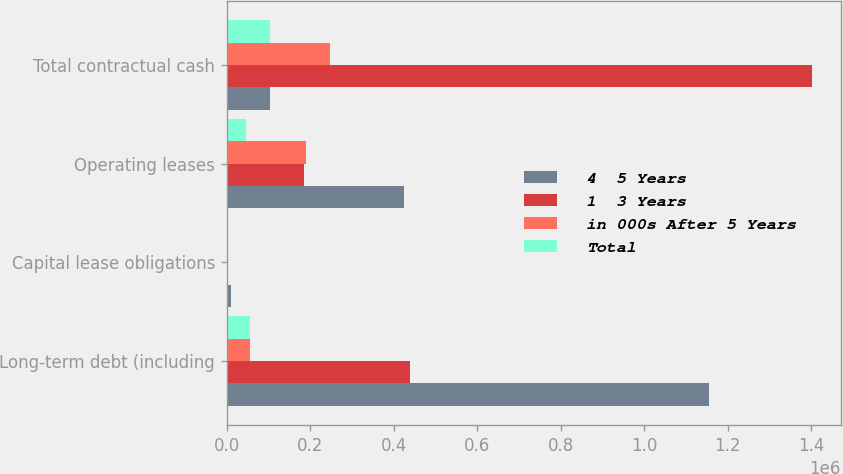<chart> <loc_0><loc_0><loc_500><loc_500><stacked_bar_chart><ecel><fcel>Long-term debt (including<fcel>Capital lease obligations<fcel>Operating leases<fcel>Total contractual cash<nl><fcel>4  5 Years<fcel>1.15479e+06<fcel>8980<fcel>423630<fcel>102292<nl><fcel>1  3 Years<fcel>437632<fcel>755<fcel>183701<fcel>1.40067e+06<nl><fcel>in 000s After 5 Years<fcel>55000<fcel>1616<fcel>189824<fcel>247805<nl><fcel>Total<fcel>55000<fcel>2007<fcel>44939<fcel>102292<nl></chart> 